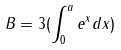Convert formula to latex. <formula><loc_0><loc_0><loc_500><loc_500>B = 3 ( \int _ { 0 } ^ { a } e ^ { x } d x )</formula> 